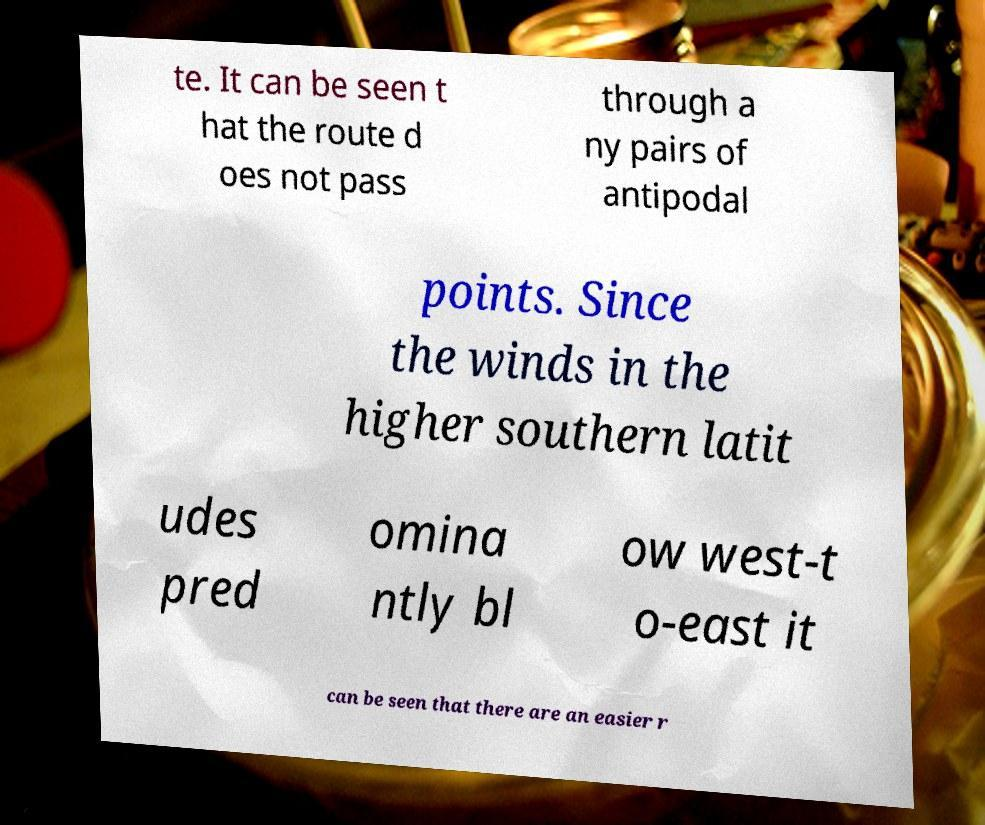There's text embedded in this image that I need extracted. Can you transcribe it verbatim? te. It can be seen t hat the route d oes not pass through a ny pairs of antipodal points. Since the winds in the higher southern latit udes pred omina ntly bl ow west-t o-east it can be seen that there are an easier r 